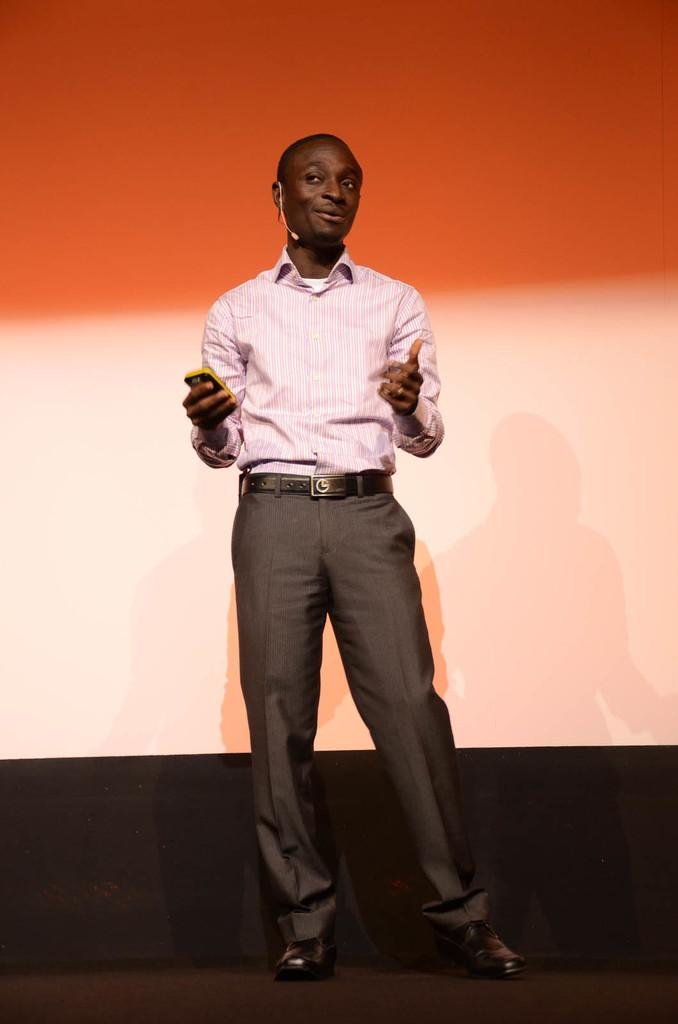What is the main subject of the image? The main subject of the image is a man. What is the man doing in the image? The man is standing in the image. What object is the man holding in his hand? The man is holding a mobile phone in his hand. What type of clothing is the man wearing? The man is wearing formal dress. What device is attached to the man's ear? There is a mouth mic on the man's ear. What can be seen in the background of the image? There is a wall in the background of the image. What is the man's theory about the moon in the image? There is no mention of the moon or any theories in the image; it only shows a man standing with a mobile phone and a mouth mic. 